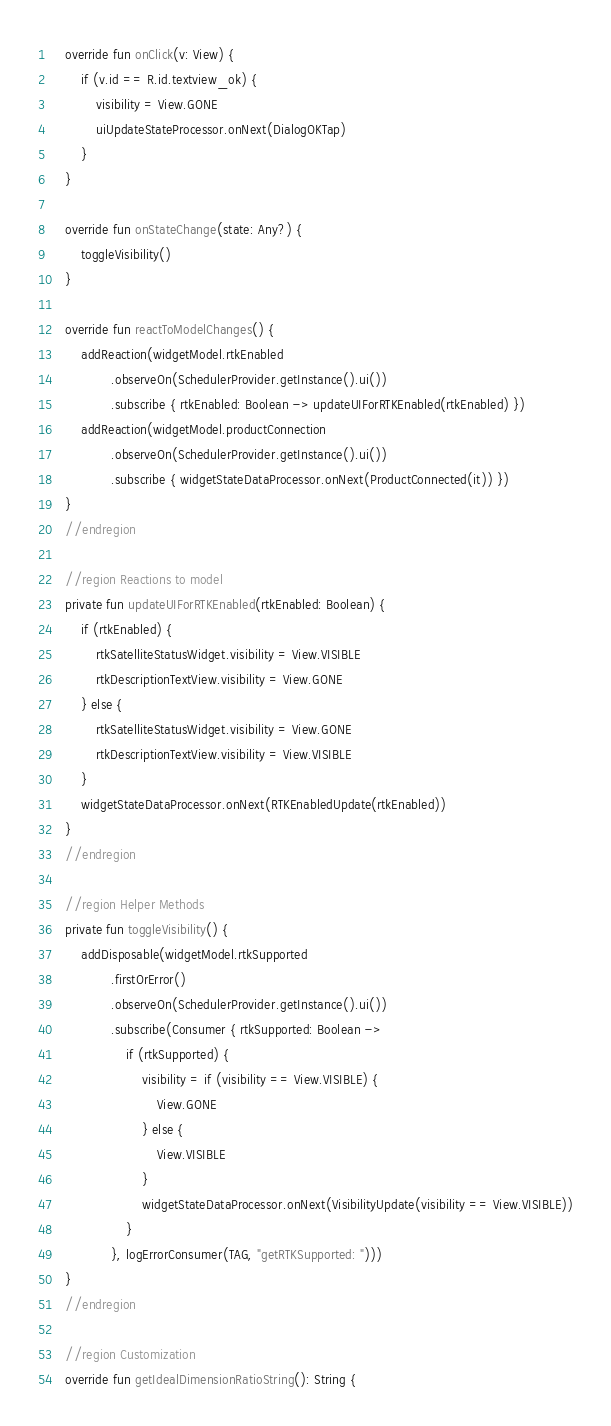<code> <loc_0><loc_0><loc_500><loc_500><_Kotlin_>    override fun onClick(v: View) {
        if (v.id == R.id.textview_ok) {
            visibility = View.GONE
            uiUpdateStateProcessor.onNext(DialogOKTap)
        }
    }

    override fun onStateChange(state: Any?) {
        toggleVisibility()
    }

    override fun reactToModelChanges() {
        addReaction(widgetModel.rtkEnabled
                .observeOn(SchedulerProvider.getInstance().ui())
                .subscribe { rtkEnabled: Boolean -> updateUIForRTKEnabled(rtkEnabled) })
        addReaction(widgetModel.productConnection
                .observeOn(SchedulerProvider.getInstance().ui())
                .subscribe { widgetStateDataProcessor.onNext(ProductConnected(it)) })
    }
    //endregion

    //region Reactions to model
    private fun updateUIForRTKEnabled(rtkEnabled: Boolean) {
        if (rtkEnabled) {
            rtkSatelliteStatusWidget.visibility = View.VISIBLE
            rtkDescriptionTextView.visibility = View.GONE
        } else {
            rtkSatelliteStatusWidget.visibility = View.GONE
            rtkDescriptionTextView.visibility = View.VISIBLE
        }
        widgetStateDataProcessor.onNext(RTKEnabledUpdate(rtkEnabled))
    }
    //endregion

    //region Helper Methods
    private fun toggleVisibility() {
        addDisposable(widgetModel.rtkSupported
                .firstOrError()
                .observeOn(SchedulerProvider.getInstance().ui())
                .subscribe(Consumer { rtkSupported: Boolean ->
                    if (rtkSupported) {
                        visibility = if (visibility == View.VISIBLE) {
                            View.GONE
                        } else {
                            View.VISIBLE
                        }
                        widgetStateDataProcessor.onNext(VisibilityUpdate(visibility == View.VISIBLE))
                    }
                }, logErrorConsumer(TAG, "getRTKSupported: ")))
    }
    //endregion

    //region Customization
    override fun getIdealDimensionRatioString(): String {</code> 